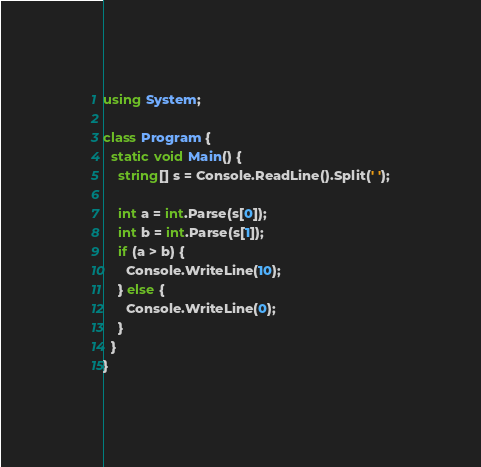<code> <loc_0><loc_0><loc_500><loc_500><_C#_>using System;

class Program {
  static void Main() {
    string[] s = Console.ReadLine().Split(' ');

    int a = int.Parse(s[0]);
    int b = int.Parse(s[1]);
    if (a > b) {
      Console.WriteLine(10);
    } else {
      Console.WriteLine(0);
    }
  }
}</code> 